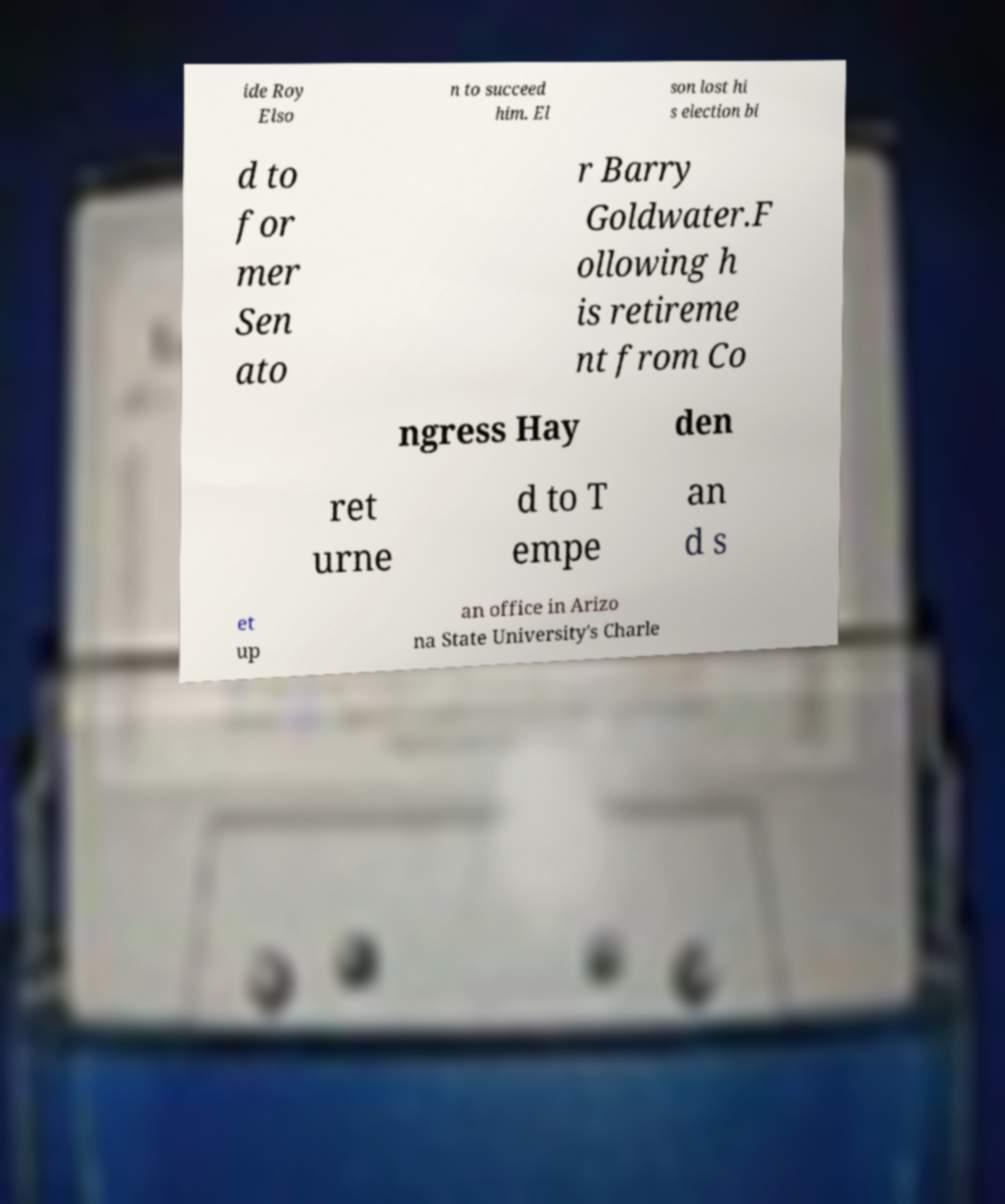Please read and relay the text visible in this image. What does it say? ide Roy Elso n to succeed him. El son lost hi s election bi d to for mer Sen ato r Barry Goldwater.F ollowing h is retireme nt from Co ngress Hay den ret urne d to T empe an d s et up an office in Arizo na State University's Charle 